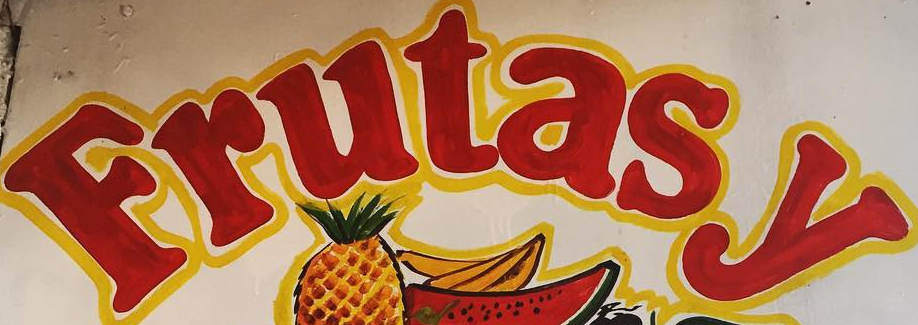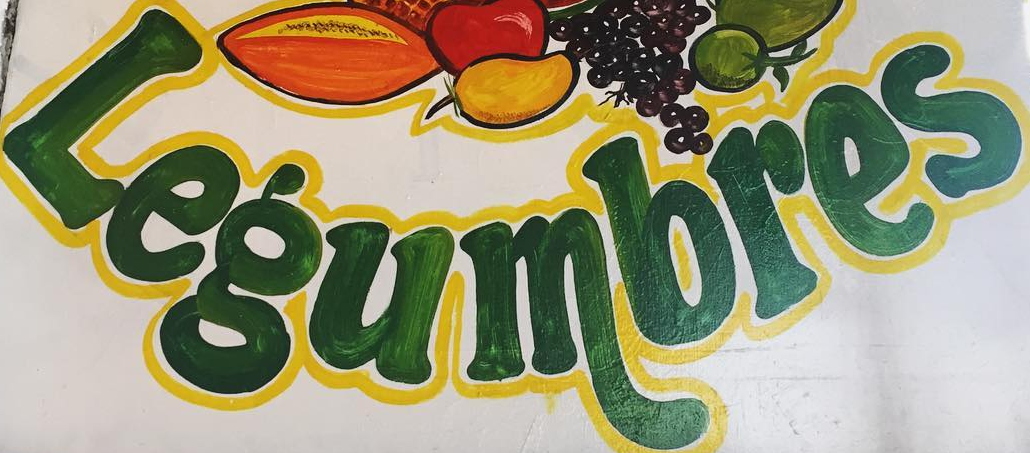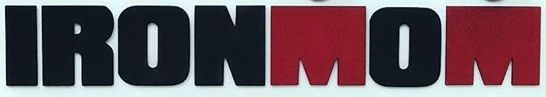What words are shown in these images in order, separated by a semicolon? Frutasy; Legumbres; IRONMOM 